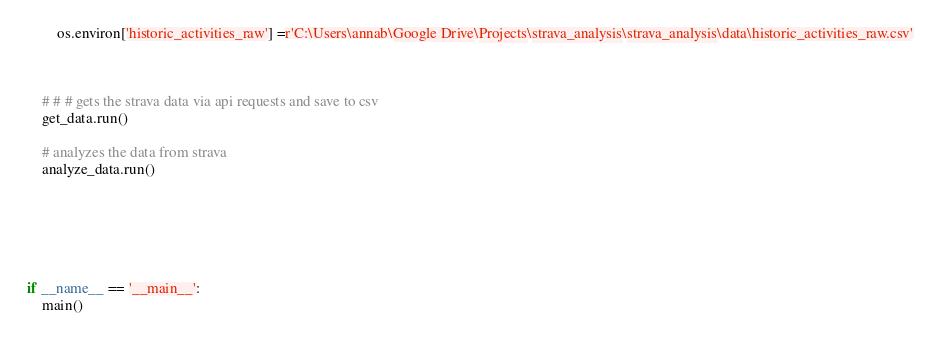Convert code to text. <code><loc_0><loc_0><loc_500><loc_500><_Python_>        os.environ['historic_activities_raw'] =r'C:\Users\annab\Google Drive\Projects\strava_analysis\strava_analysis\data\historic_activities_raw.csv'


  
    # # # gets the strava data via api requests and save to csv
    get_data.run()

    # analyzes the data from strava
    analyze_data.run()
    





if __name__ == '__main__':
    main()</code> 